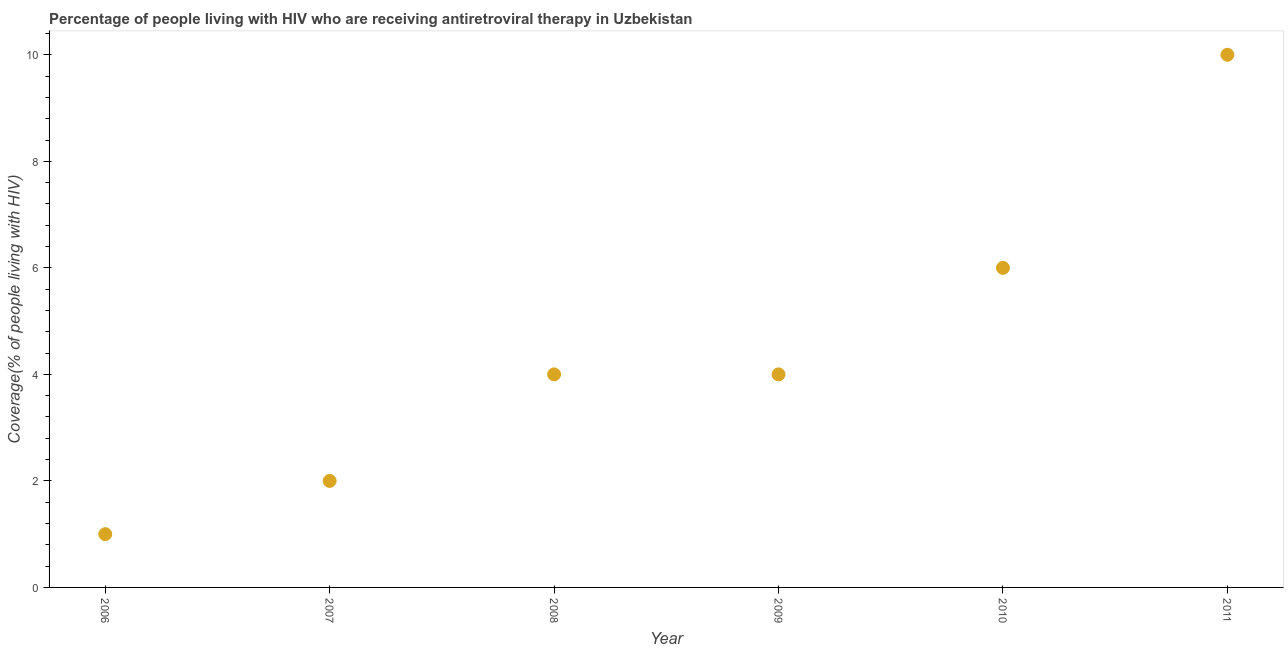What is the antiretroviral therapy coverage in 2008?
Your answer should be very brief. 4. Across all years, what is the maximum antiretroviral therapy coverage?
Your answer should be very brief. 10. Across all years, what is the minimum antiretroviral therapy coverage?
Provide a short and direct response. 1. In which year was the antiretroviral therapy coverage maximum?
Your answer should be very brief. 2011. What is the sum of the antiretroviral therapy coverage?
Make the answer very short. 27. What is the difference between the antiretroviral therapy coverage in 2008 and 2011?
Keep it short and to the point. -6. What is the average antiretroviral therapy coverage per year?
Your response must be concise. 4.5. What is the median antiretroviral therapy coverage?
Provide a short and direct response. 4. Do a majority of the years between 2009 and 2007 (inclusive) have antiretroviral therapy coverage greater than 2.4 %?
Provide a short and direct response. No. What is the ratio of the antiretroviral therapy coverage in 2006 to that in 2011?
Your answer should be compact. 0.1. Is the antiretroviral therapy coverage in 2008 less than that in 2011?
Keep it short and to the point. Yes. What is the difference between the highest and the second highest antiretroviral therapy coverage?
Provide a succinct answer. 4. Is the sum of the antiretroviral therapy coverage in 2007 and 2009 greater than the maximum antiretroviral therapy coverage across all years?
Provide a short and direct response. No. What is the difference between the highest and the lowest antiretroviral therapy coverage?
Keep it short and to the point. 9. In how many years, is the antiretroviral therapy coverage greater than the average antiretroviral therapy coverage taken over all years?
Provide a short and direct response. 2. Does the antiretroviral therapy coverage monotonically increase over the years?
Provide a short and direct response. No. How many years are there in the graph?
Provide a succinct answer. 6. Are the values on the major ticks of Y-axis written in scientific E-notation?
Give a very brief answer. No. Does the graph contain any zero values?
Keep it short and to the point. No. Does the graph contain grids?
Offer a very short reply. No. What is the title of the graph?
Provide a succinct answer. Percentage of people living with HIV who are receiving antiretroviral therapy in Uzbekistan. What is the label or title of the Y-axis?
Make the answer very short. Coverage(% of people living with HIV). What is the Coverage(% of people living with HIV) in 2006?
Ensure brevity in your answer.  1. What is the difference between the Coverage(% of people living with HIV) in 2006 and 2007?
Your answer should be very brief. -1. What is the difference between the Coverage(% of people living with HIV) in 2006 and 2008?
Keep it short and to the point. -3. What is the difference between the Coverage(% of people living with HIV) in 2006 and 2009?
Provide a short and direct response. -3. What is the difference between the Coverage(% of people living with HIV) in 2006 and 2010?
Keep it short and to the point. -5. What is the difference between the Coverage(% of people living with HIV) in 2007 and 2008?
Offer a very short reply. -2. What is the difference between the Coverage(% of people living with HIV) in 2007 and 2009?
Offer a very short reply. -2. What is the difference between the Coverage(% of people living with HIV) in 2007 and 2010?
Offer a very short reply. -4. What is the difference between the Coverage(% of people living with HIV) in 2007 and 2011?
Offer a terse response. -8. What is the difference between the Coverage(% of people living with HIV) in 2008 and 2009?
Offer a terse response. 0. What is the difference between the Coverage(% of people living with HIV) in 2008 and 2011?
Offer a very short reply. -6. What is the difference between the Coverage(% of people living with HIV) in 2009 and 2010?
Offer a terse response. -2. What is the difference between the Coverage(% of people living with HIV) in 2009 and 2011?
Provide a short and direct response. -6. What is the difference between the Coverage(% of people living with HIV) in 2010 and 2011?
Your answer should be very brief. -4. What is the ratio of the Coverage(% of people living with HIV) in 2006 to that in 2007?
Offer a terse response. 0.5. What is the ratio of the Coverage(% of people living with HIV) in 2006 to that in 2008?
Offer a terse response. 0.25. What is the ratio of the Coverage(% of people living with HIV) in 2006 to that in 2009?
Provide a succinct answer. 0.25. What is the ratio of the Coverage(% of people living with HIV) in 2006 to that in 2010?
Make the answer very short. 0.17. What is the ratio of the Coverage(% of people living with HIV) in 2006 to that in 2011?
Your response must be concise. 0.1. What is the ratio of the Coverage(% of people living with HIV) in 2007 to that in 2008?
Your answer should be compact. 0.5. What is the ratio of the Coverage(% of people living with HIV) in 2007 to that in 2010?
Your answer should be very brief. 0.33. What is the ratio of the Coverage(% of people living with HIV) in 2008 to that in 2010?
Provide a succinct answer. 0.67. What is the ratio of the Coverage(% of people living with HIV) in 2008 to that in 2011?
Your answer should be very brief. 0.4. What is the ratio of the Coverage(% of people living with HIV) in 2009 to that in 2010?
Your answer should be very brief. 0.67. What is the ratio of the Coverage(% of people living with HIV) in 2010 to that in 2011?
Ensure brevity in your answer.  0.6. 